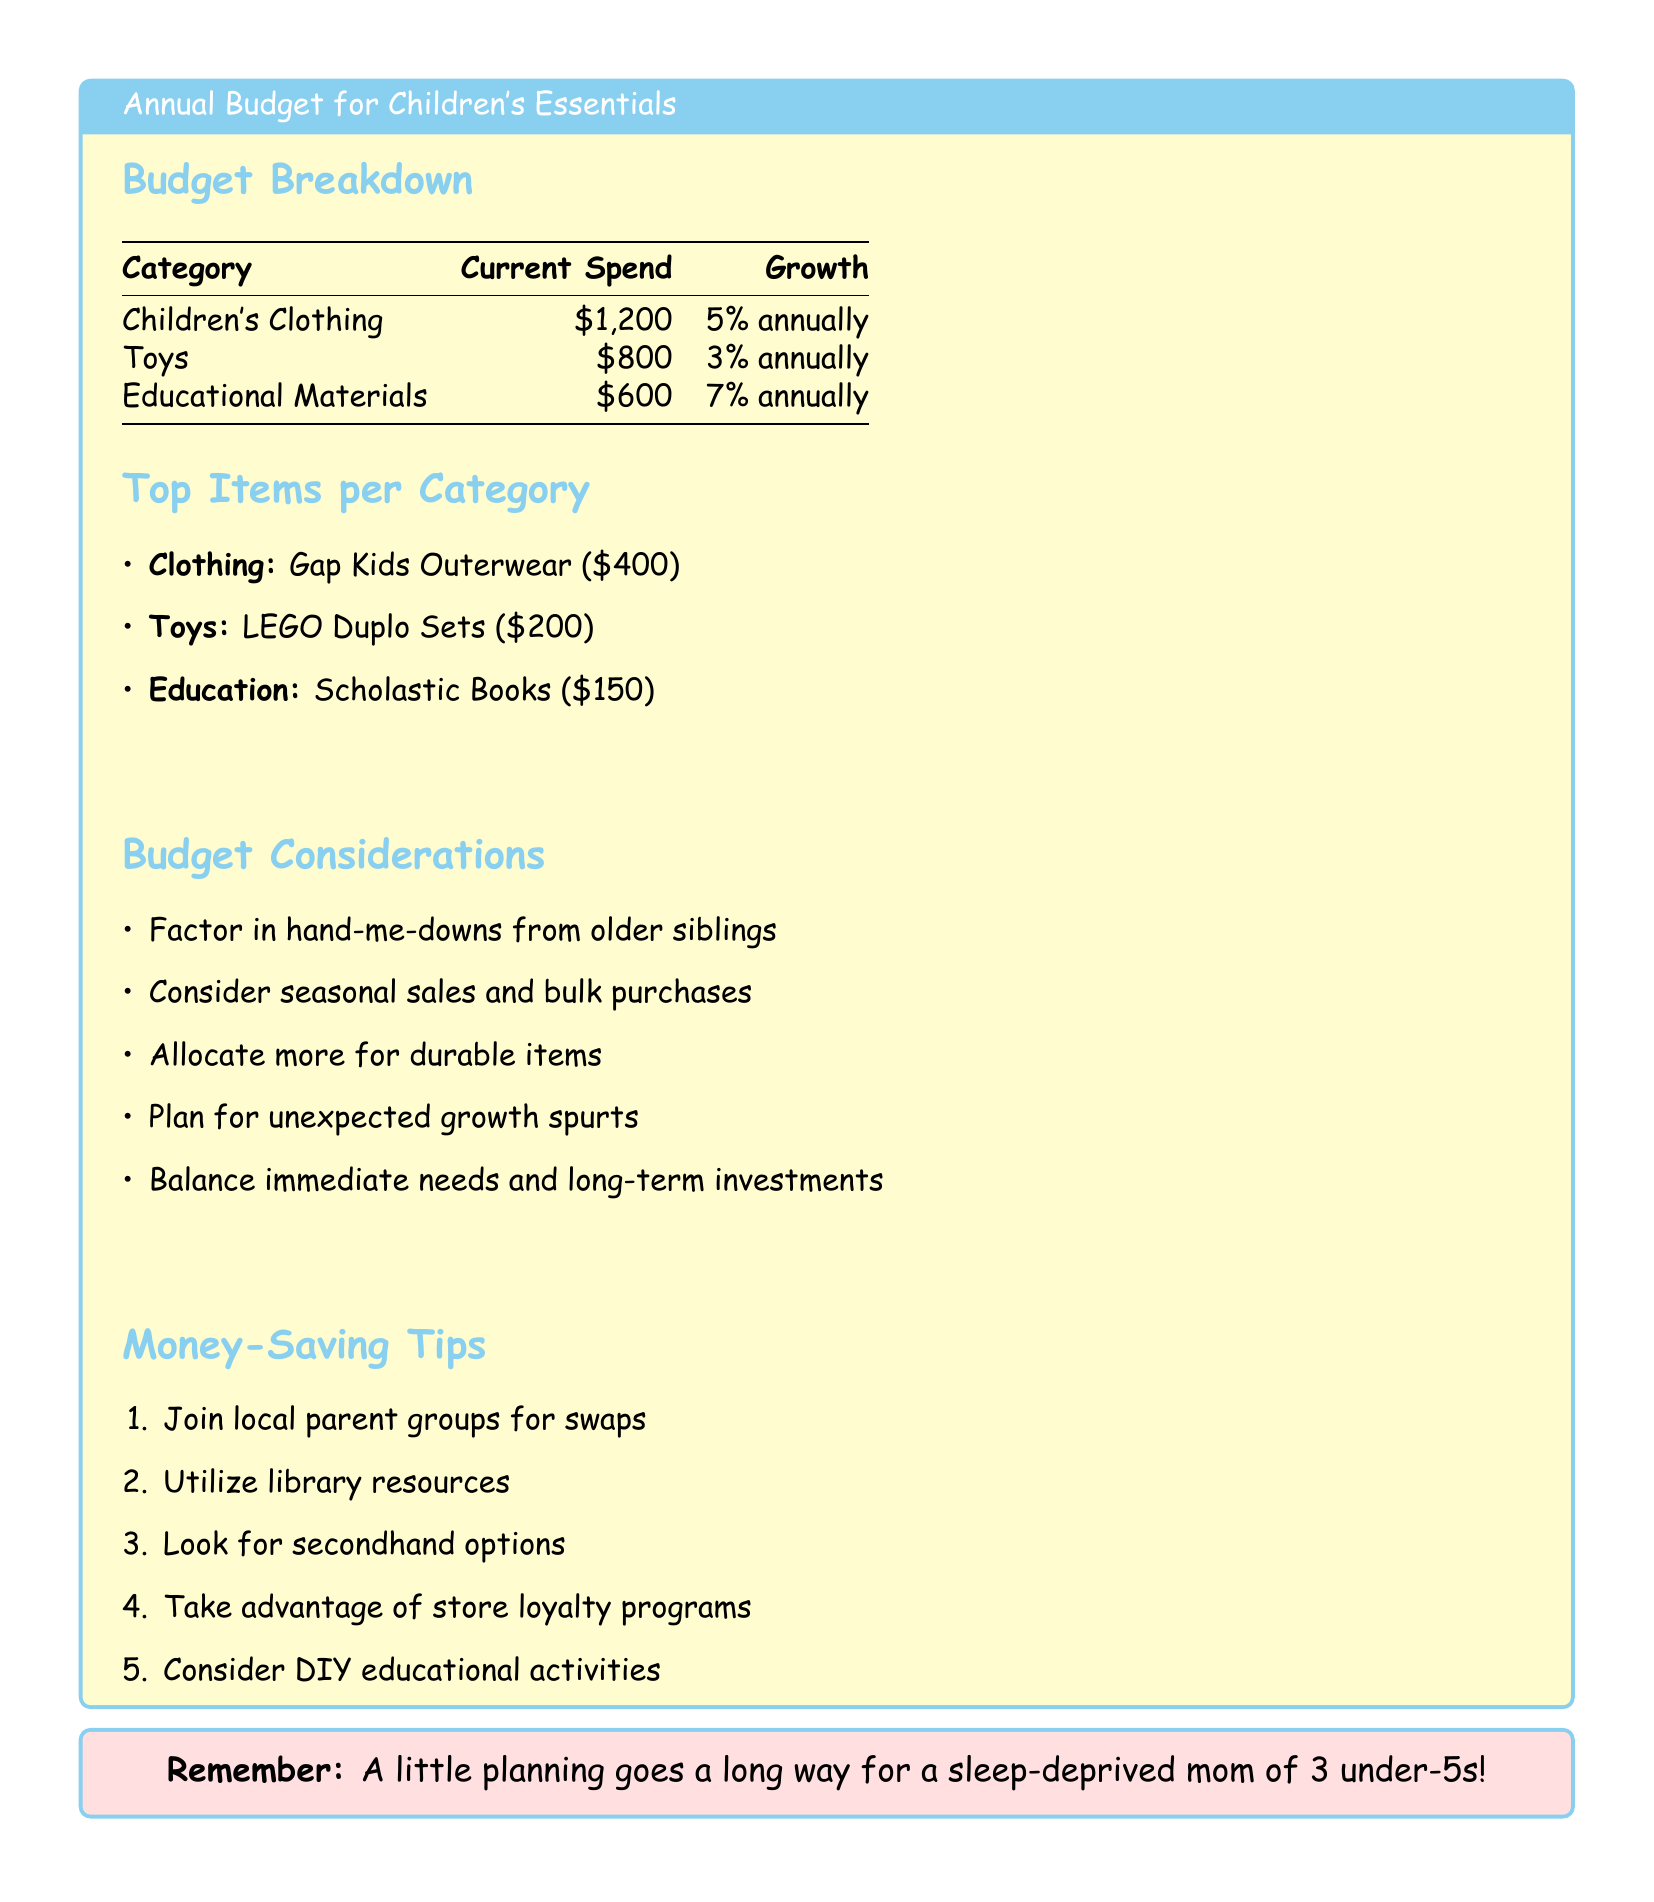What is the current spend on children's clothing? The document states that the current spend on children's clothing is $1,200.
Answer: $1,200 What is the growth rate for educational materials? According to the budget, educational materials have a growth rate of 7% annually.
Answer: 7% What is the top item listed under toys? The document identifies LEGO Duplo Sets as the top item in the toys category.
Answer: LEGO Duplo Sets How much is allocated for toys in the annual budget? The budget allocates $800 for toys.
Answer: $800 What budget consideration involves sibling clothes? The document mentions factoring in hand-me-downs from older siblings as a budget consideration.
Answer: Hand-me-downs Which category has the lowest growth rate? The toys category has the lowest growth rate at 3% annually.
Answer: 3% What is the emphasized message in the soft pink box? The message encourages planning for a sleep-deprived mom of 3 under-5s.
Answer: A little planning goes a long way for a sleep-deprived mom of 3 under-5s! How much is allocated for educational materials? The annual budget allocates $600 for educational materials.
Answer: $600 What money-saving tip involves community support? Joining local parent groups for swaps is a suggested money-saving tip.
Answer: Join local parent groups for swaps 